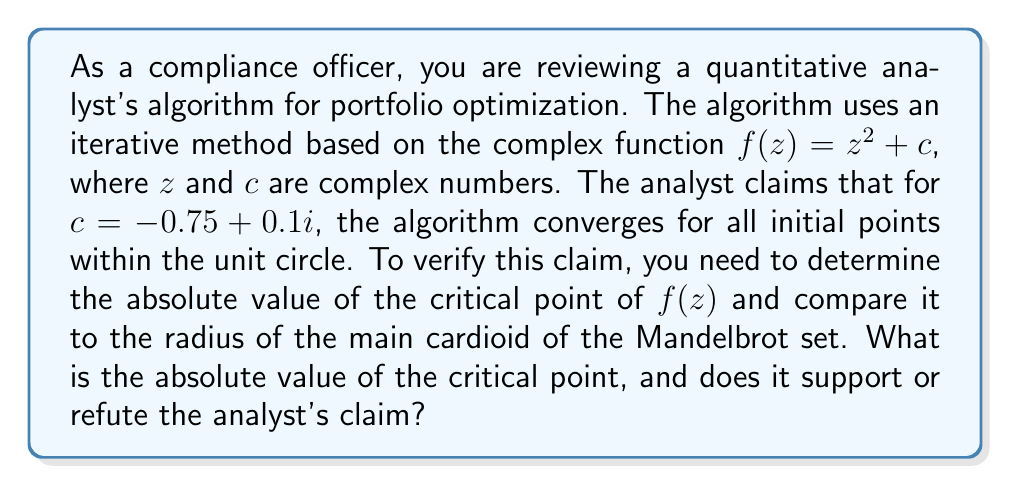Provide a solution to this math problem. To evaluate the convergence of this iterative algorithm using complex dynamics, we need to follow these steps:

1) First, let's recall that the critical point of $f(z) = z^2 + c$ is always at $z = 0$. This is because $f'(z) = 2z$, and $f'(z) = 0$ when $z = 0$.

2) The critical value is $f(0) = c = -0.75 + 0.1i$.

3) To find the absolute value of the critical value:

   $$|c| = \sqrt{(-0.75)^2 + (0.1)^2} = \sqrt{0.5625 + 0.01} = \sqrt{0.5725} \approx 0.7566$$

4) Now, we need to compare this to the radius of the main cardioid of the Mandelbrot set. The boundary of the main cardioid is given by the equation:

   $$c = \frac{1}{2}e^{i\theta} - \frac{1}{4}e^{2i\theta}$$

   where $\theta$ ranges from 0 to $2\pi$.

5) The maximum radius of the main cardioid occurs at $\theta = 0$ and is equal to $1/4$.

6) Since $|c| \approx 0.7566 > 1/4$, the critical value lies outside the main cardioid of the Mandelbrot set.

7) This means that the iterative algorithm does not converge for all initial points within the unit circle. In fact, it will only converge for a subset of points within the unit circle.

Therefore, this analysis refutes the analyst's claim. The algorithm does not converge for all initial points within the unit circle when $c = -0.75 + 0.1i$.
Answer: The absolute value of the critical point is approximately 0.7566. This value being greater than 1/4 (the radius of the main cardioid of the Mandelbrot set) refutes the analyst's claim. The algorithm does not converge for all initial points within the unit circle for the given value of $c$. 